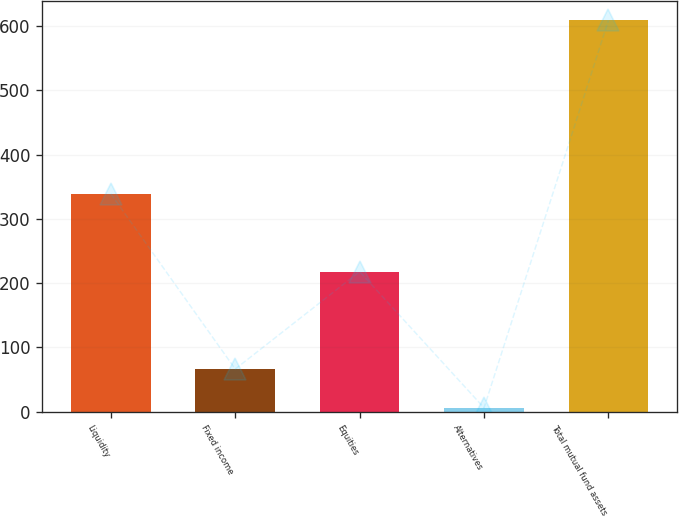Convert chart to OTSL. <chart><loc_0><loc_0><loc_500><loc_500><bar_chart><fcel>Liquidity<fcel>Fixed income<fcel>Equities<fcel>Alternatives<fcel>Total mutual fund assets<nl><fcel>339<fcel>66.3<fcel>218<fcel>6<fcel>609<nl></chart> 